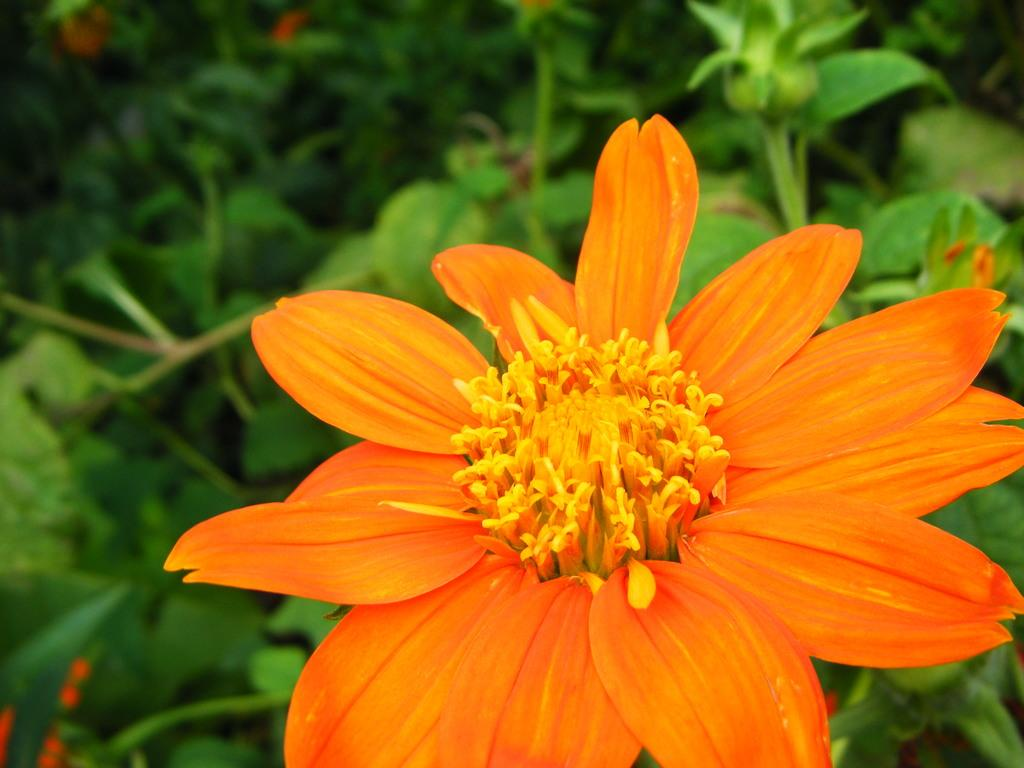What type of living organisms can be seen in the image? There are flowers on plants in the image. Can you describe the plants in the image? The plants in the image have flowers on them. What type of kitten can be seen playing with a brake in the image? There is no kitten or brake present in the image; it only features flowers on plants. What arithmetic problem is being solved by the flowers in the image? There is no arithmetic problem being solved by the flowers in the image; they are simply plants with flowers on them. 